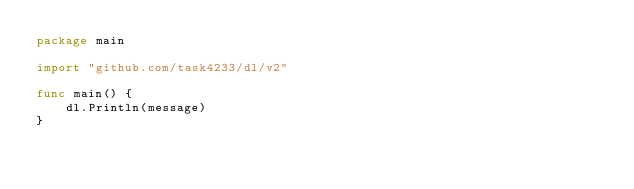Convert code to text. <code><loc_0><loc_0><loc_500><loc_500><_Go_>package main

import "github.com/task4233/dl/v2"

func main() {
	dl.Println(message)
}
</code> 